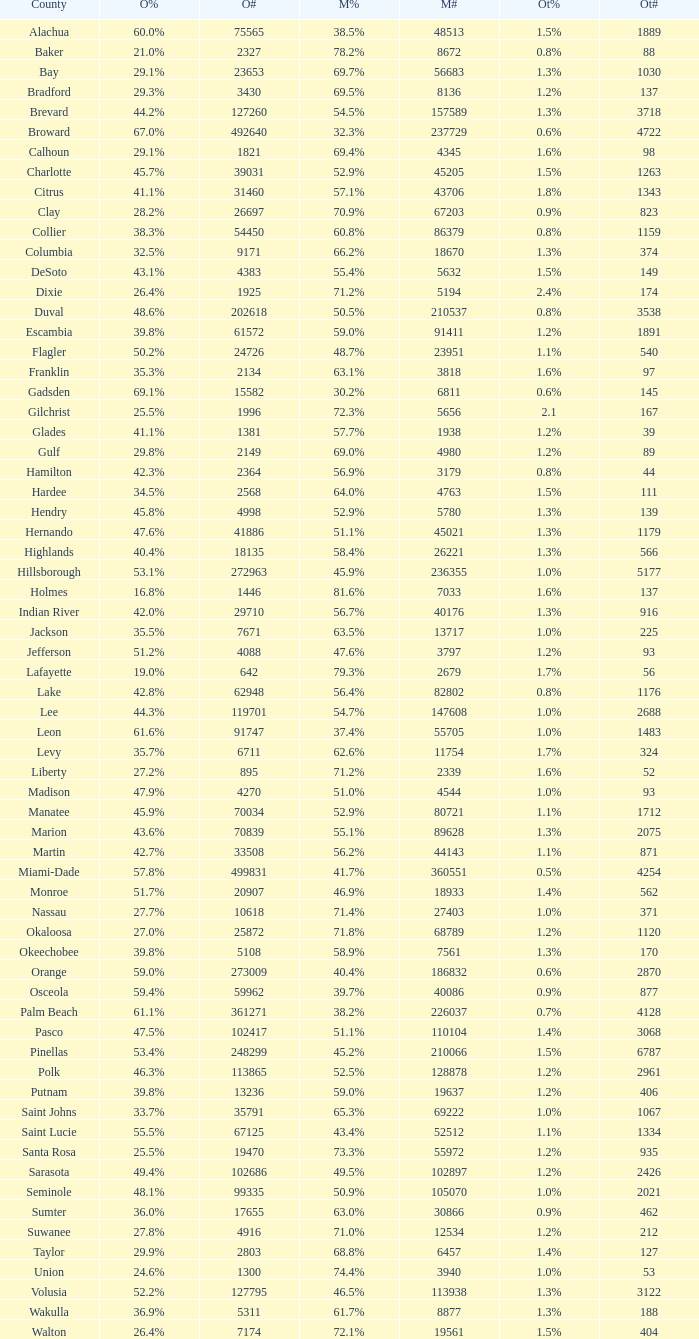0 voters? 1.3%. 